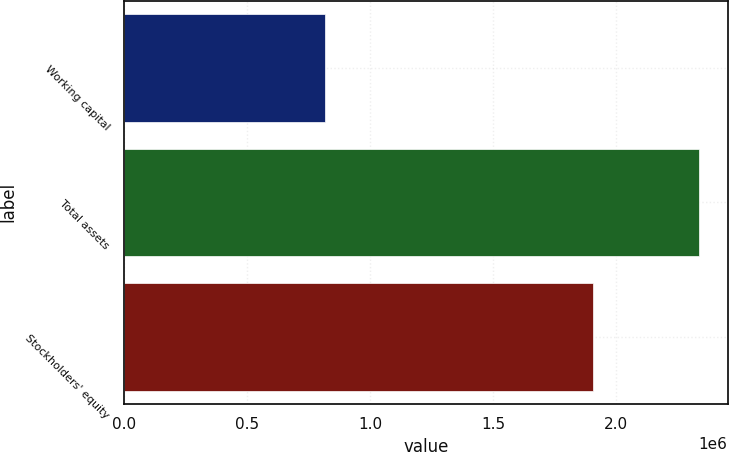<chart> <loc_0><loc_0><loc_500><loc_500><bar_chart><fcel>Working capital<fcel>Total assets<fcel>Stockholders' equity<nl><fcel>814602<fcel>2.33536e+06<fcel>1.90374e+06<nl></chart> 